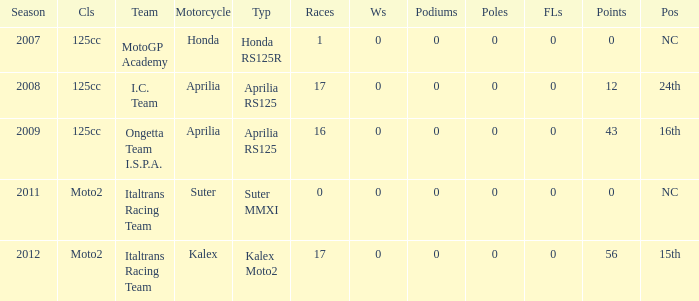What's the number of poles in the season where the team had a Kalex motorcycle? 0.0. 